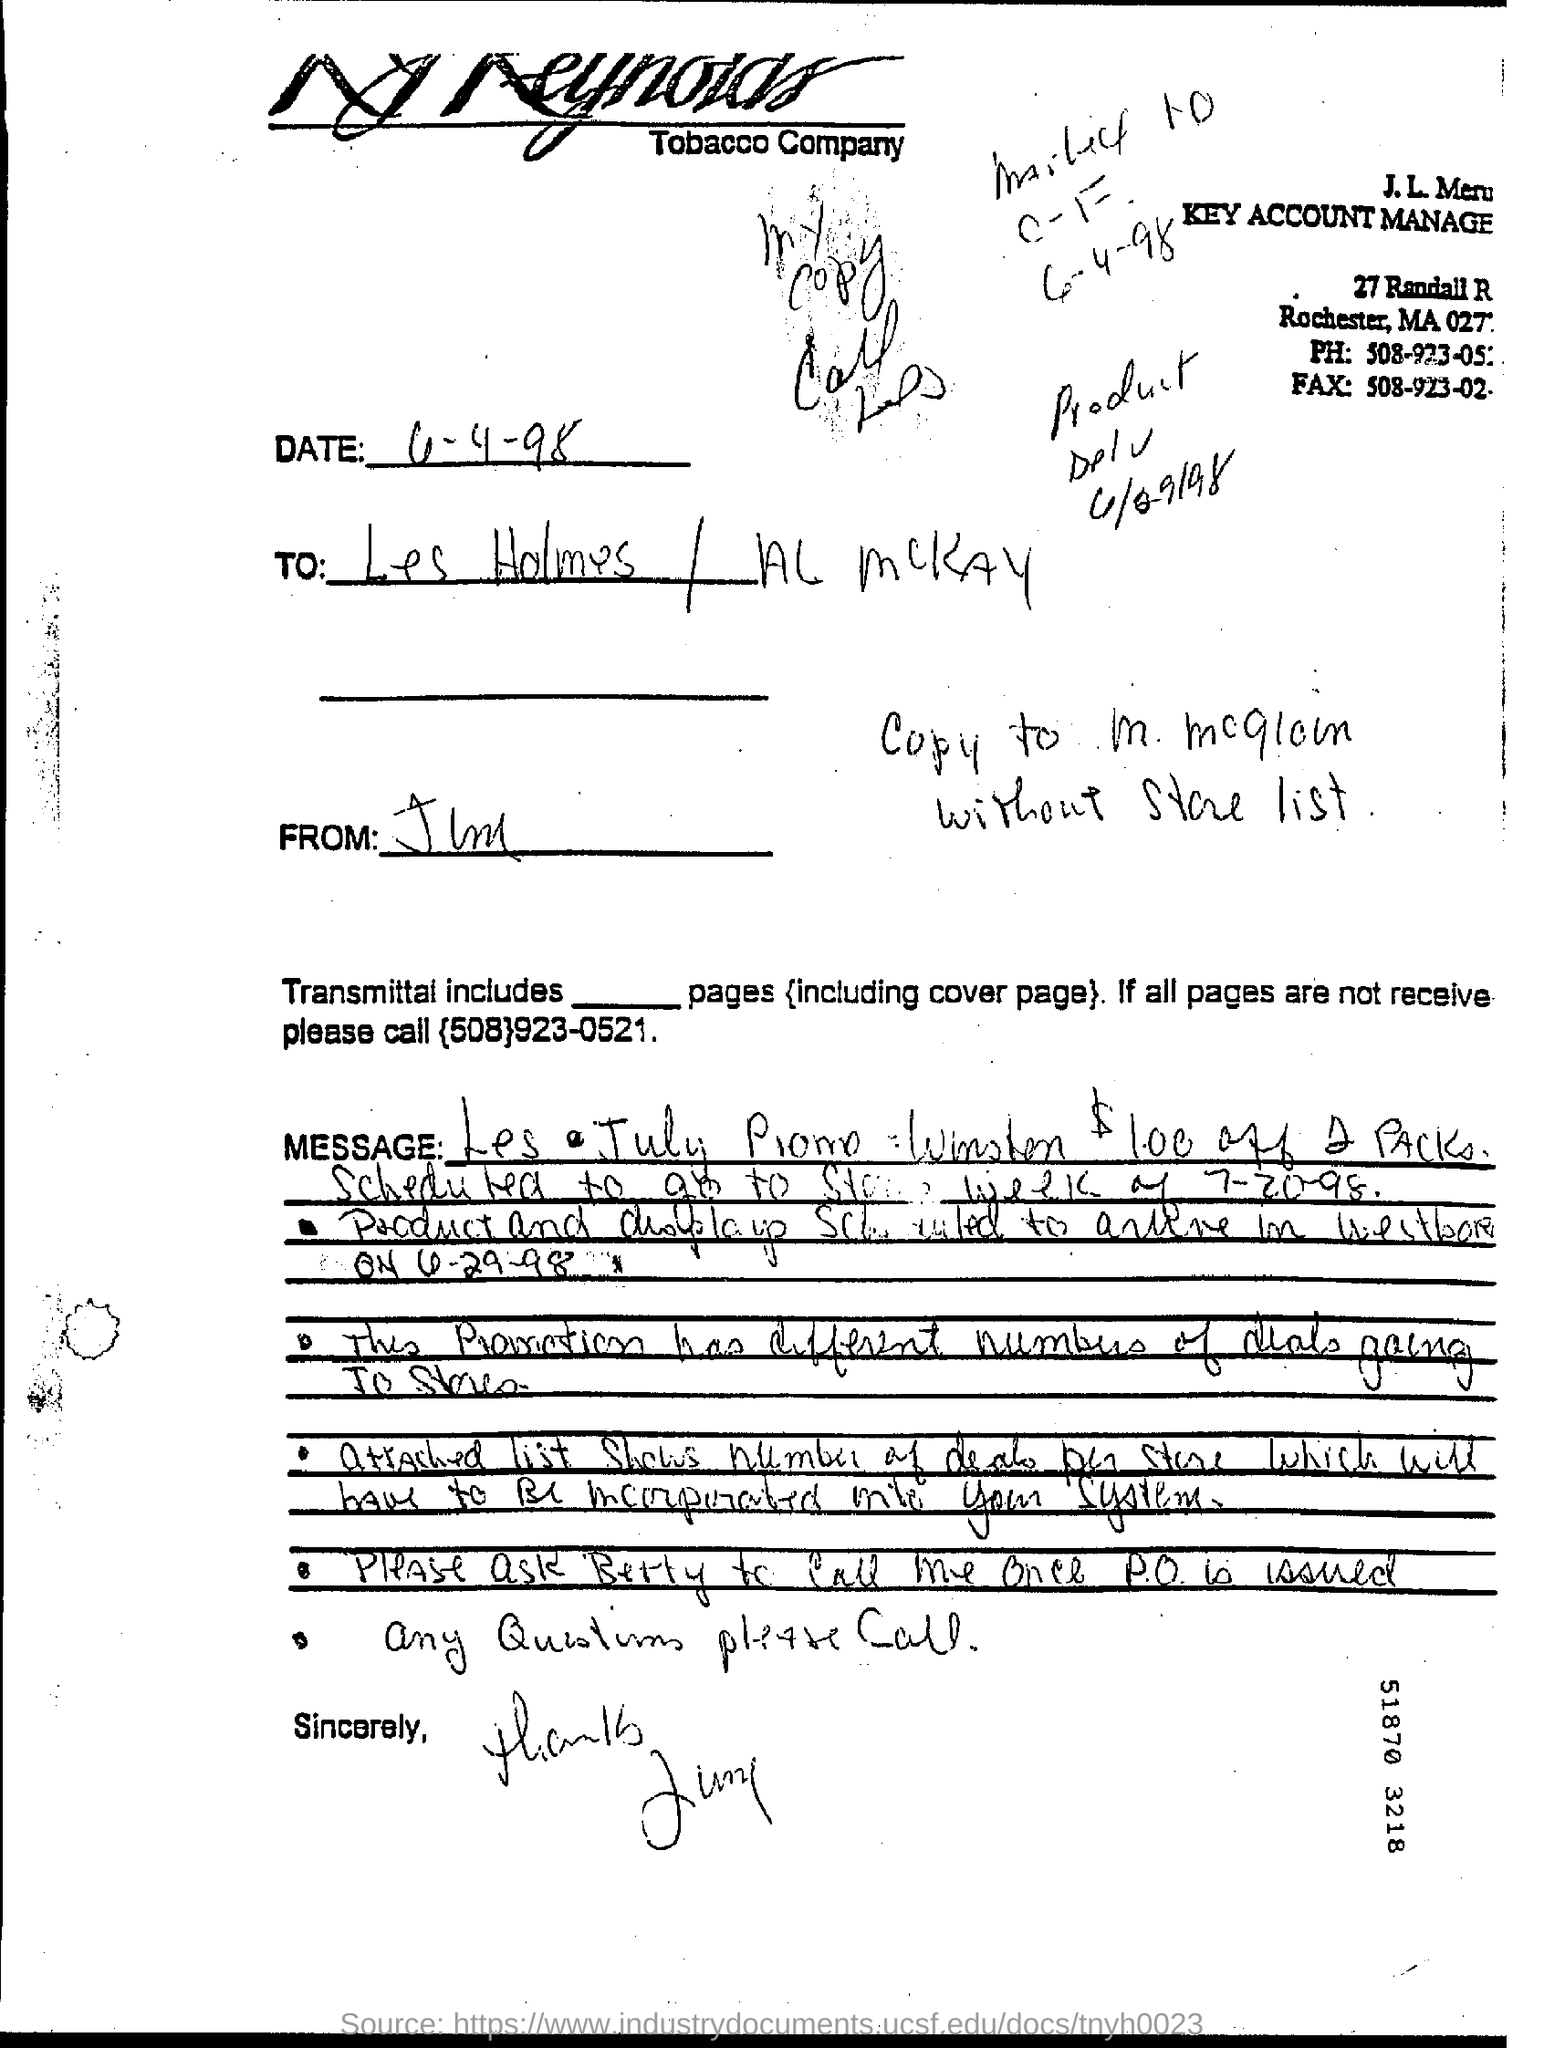What is the line written just above "sincerely"?
Offer a terse response. Any questions please call. 